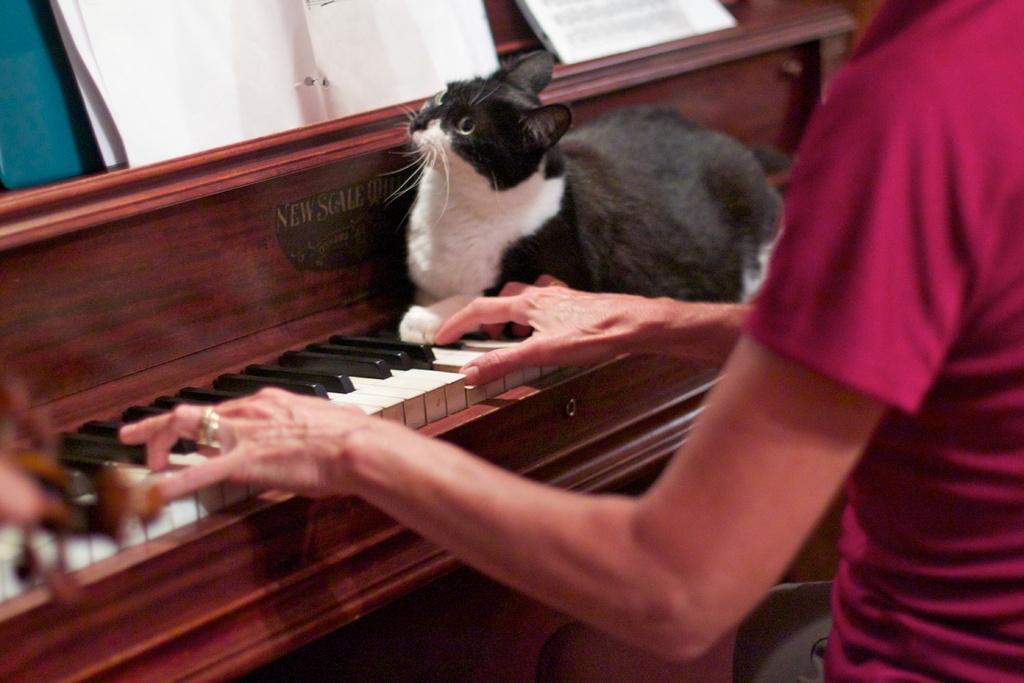Describe this image in one or two sentences. In this image I can see a person sitting in front of the piano. On the piano there is a cat. 